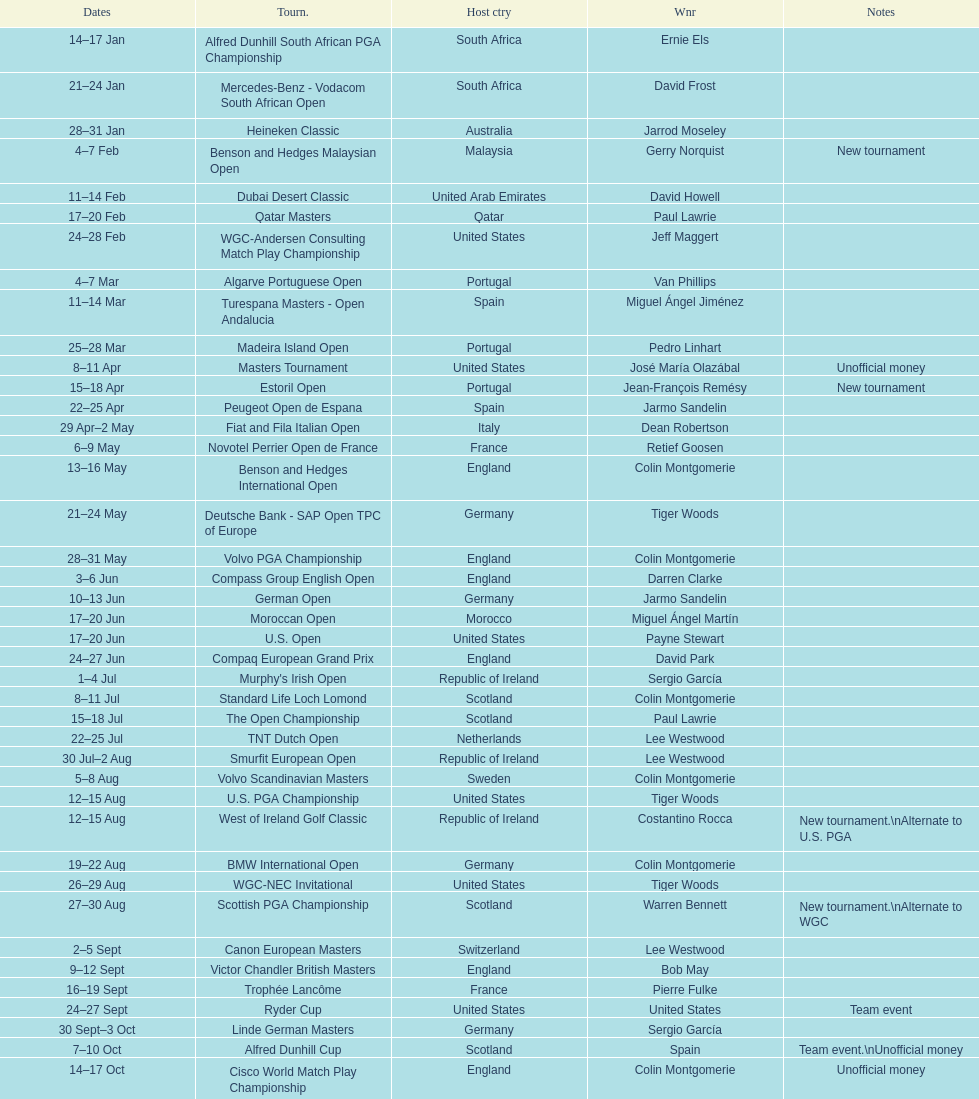Can you parse all the data within this table? {'header': ['Dates', 'Tourn.', 'Host ctry', 'Wnr', 'Notes'], 'rows': [['14–17\xa0Jan', 'Alfred Dunhill South African PGA Championship', 'South Africa', 'Ernie Els', ''], ['21–24\xa0Jan', 'Mercedes-Benz - Vodacom South African Open', 'South Africa', 'David Frost', ''], ['28–31\xa0Jan', 'Heineken Classic', 'Australia', 'Jarrod Moseley', ''], ['4–7\xa0Feb', 'Benson and Hedges Malaysian Open', 'Malaysia', 'Gerry Norquist', 'New tournament'], ['11–14\xa0Feb', 'Dubai Desert Classic', 'United Arab Emirates', 'David Howell', ''], ['17–20\xa0Feb', 'Qatar Masters', 'Qatar', 'Paul Lawrie', ''], ['24–28\xa0Feb', 'WGC-Andersen Consulting Match Play Championship', 'United States', 'Jeff Maggert', ''], ['4–7\xa0Mar', 'Algarve Portuguese Open', 'Portugal', 'Van Phillips', ''], ['11–14\xa0Mar', 'Turespana Masters - Open Andalucia', 'Spain', 'Miguel Ángel Jiménez', ''], ['25–28\xa0Mar', 'Madeira Island Open', 'Portugal', 'Pedro Linhart', ''], ['8–11\xa0Apr', 'Masters Tournament', 'United States', 'José María Olazábal', 'Unofficial money'], ['15–18\xa0Apr', 'Estoril Open', 'Portugal', 'Jean-François Remésy', 'New tournament'], ['22–25\xa0Apr', 'Peugeot Open de Espana', 'Spain', 'Jarmo Sandelin', ''], ['29\xa0Apr–2\xa0May', 'Fiat and Fila Italian Open', 'Italy', 'Dean Robertson', ''], ['6–9\xa0May', 'Novotel Perrier Open de France', 'France', 'Retief Goosen', ''], ['13–16\xa0May', 'Benson and Hedges International Open', 'England', 'Colin Montgomerie', ''], ['21–24\xa0May', 'Deutsche Bank - SAP Open TPC of Europe', 'Germany', 'Tiger Woods', ''], ['28–31\xa0May', 'Volvo PGA Championship', 'England', 'Colin Montgomerie', ''], ['3–6\xa0Jun', 'Compass Group English Open', 'England', 'Darren Clarke', ''], ['10–13\xa0Jun', 'German Open', 'Germany', 'Jarmo Sandelin', ''], ['17–20\xa0Jun', 'Moroccan Open', 'Morocco', 'Miguel Ángel Martín', ''], ['17–20\xa0Jun', 'U.S. Open', 'United States', 'Payne Stewart', ''], ['24–27\xa0Jun', 'Compaq European Grand Prix', 'England', 'David Park', ''], ['1–4\xa0Jul', "Murphy's Irish Open", 'Republic of Ireland', 'Sergio García', ''], ['8–11\xa0Jul', 'Standard Life Loch Lomond', 'Scotland', 'Colin Montgomerie', ''], ['15–18\xa0Jul', 'The Open Championship', 'Scotland', 'Paul Lawrie', ''], ['22–25\xa0Jul', 'TNT Dutch Open', 'Netherlands', 'Lee Westwood', ''], ['30\xa0Jul–2\xa0Aug', 'Smurfit European Open', 'Republic of Ireland', 'Lee Westwood', ''], ['5–8\xa0Aug', 'Volvo Scandinavian Masters', 'Sweden', 'Colin Montgomerie', ''], ['12–15\xa0Aug', 'U.S. PGA Championship', 'United States', 'Tiger Woods', ''], ['12–15\xa0Aug', 'West of Ireland Golf Classic', 'Republic of Ireland', 'Costantino Rocca', 'New tournament.\\nAlternate to U.S. PGA'], ['19–22\xa0Aug', 'BMW International Open', 'Germany', 'Colin Montgomerie', ''], ['26–29\xa0Aug', 'WGC-NEC Invitational', 'United States', 'Tiger Woods', ''], ['27–30\xa0Aug', 'Scottish PGA Championship', 'Scotland', 'Warren Bennett', 'New tournament.\\nAlternate to WGC'], ['2–5\xa0Sept', 'Canon European Masters', 'Switzerland', 'Lee Westwood', ''], ['9–12\xa0Sept', 'Victor Chandler British Masters', 'England', 'Bob May', ''], ['16–19\xa0Sept', 'Trophée Lancôme', 'France', 'Pierre Fulke', ''], ['24–27\xa0Sept', 'Ryder Cup', 'United States', 'United States', 'Team event'], ['30\xa0Sept–3\xa0Oct', 'Linde German Masters', 'Germany', 'Sergio García', ''], ['7–10\xa0Oct', 'Alfred Dunhill Cup', 'Scotland', 'Spain', 'Team event.\\nUnofficial money'], ['14–17\xa0Oct', 'Cisco World Match Play Championship', 'England', 'Colin Montgomerie', 'Unofficial money'], ['14–17\xa0Oct', 'Sarazen World Open', 'Spain', 'Thomas Bjørn', 'New tournament'], ['21–24\xa0Oct', 'Belgacom Open', 'Belgium', 'Robert Karlsson', ''], ['28–31\xa0Oct', 'Volvo Masters', 'Spain', 'Miguel Ángel Jiménez', ''], ['4–7\xa0Nov', 'WGC-American Express Championship', 'Spain', 'Tiger Woods', ''], ['18–21\xa0Nov', 'World Cup of Golf', 'Malaysia', 'United States', 'Team event.\\nUnofficial money']]} What was the country listed the first time there was a new tournament? Malaysia. 